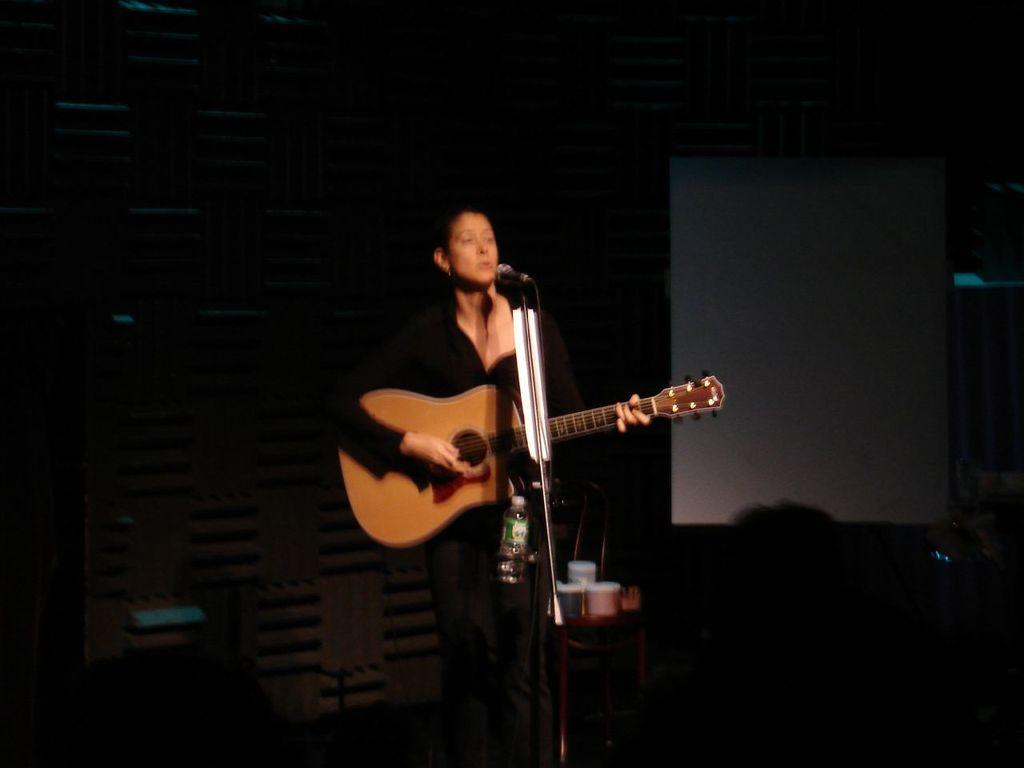What is the woman in the image doing? The woman is playing a guitar and singing a song. What object is in front of the woman? There is a microphone in front of the woman. What might the woman be using to stay hydrated while performing? There is a water bottle present in the image. What type of feather can be seen floating in the air during the woman's performance? There is no feather present in the image, and therefore no such object can be observed. 